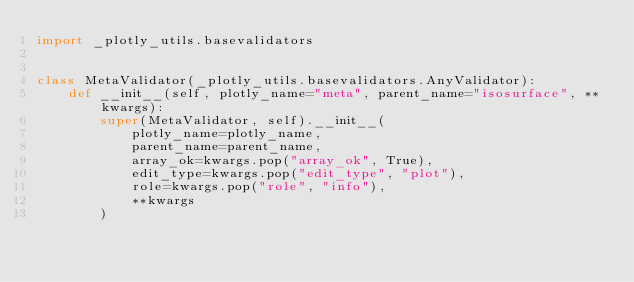<code> <loc_0><loc_0><loc_500><loc_500><_Python_>import _plotly_utils.basevalidators


class MetaValidator(_plotly_utils.basevalidators.AnyValidator):
    def __init__(self, plotly_name="meta", parent_name="isosurface", **kwargs):
        super(MetaValidator, self).__init__(
            plotly_name=plotly_name,
            parent_name=parent_name,
            array_ok=kwargs.pop("array_ok", True),
            edit_type=kwargs.pop("edit_type", "plot"),
            role=kwargs.pop("role", "info"),
            **kwargs
        )
</code> 